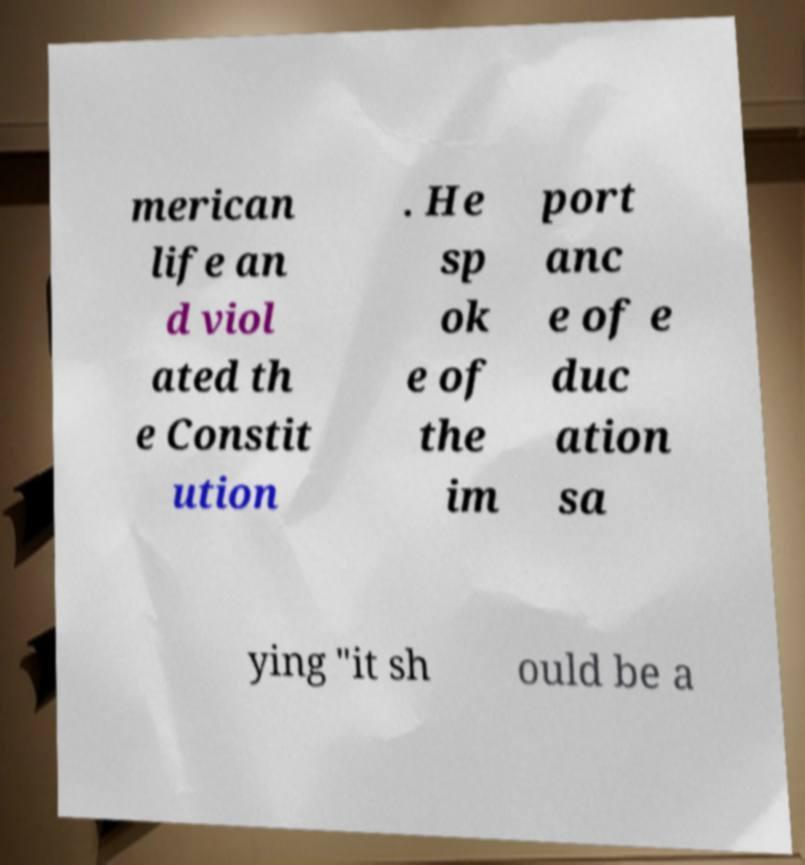Can you accurately transcribe the text from the provided image for me? merican life an d viol ated th e Constit ution . He sp ok e of the im port anc e of e duc ation sa ying "it sh ould be a 